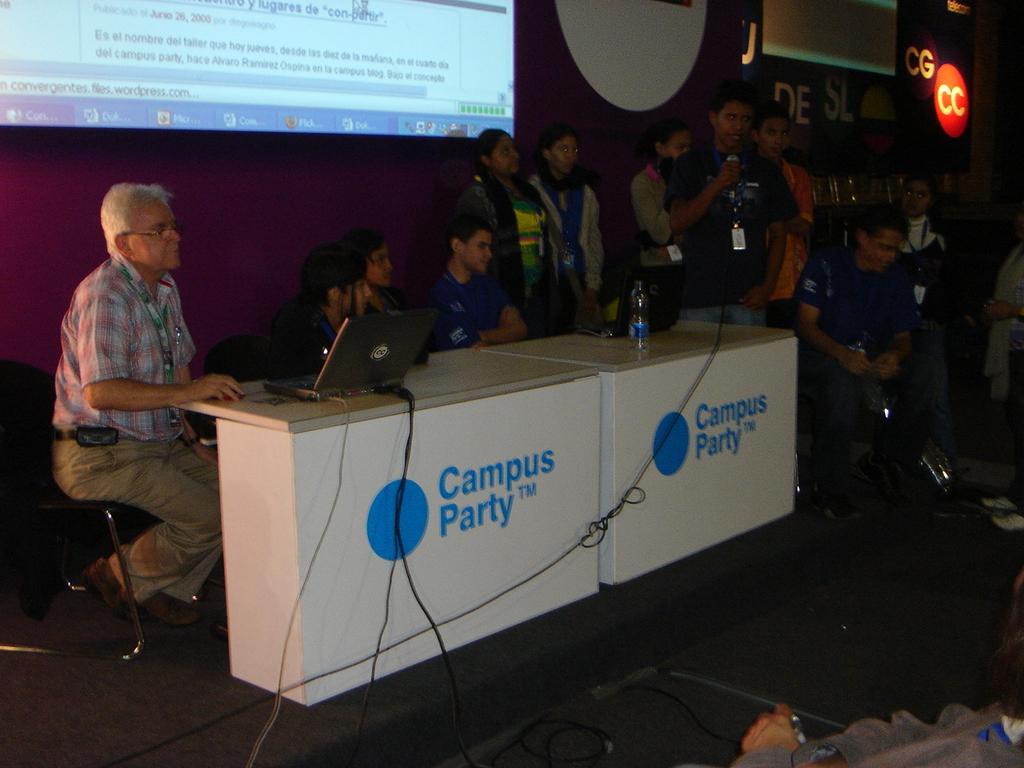How would you summarize this image in a sentence or two? There is stage. On that there is a table and something is written on that. On the table there are laptops and a bottle. Beside that some people are sitting and standing. And a person is holding a mic and standing. In the back there's a wall. On that there is a screen and something is written on that. 